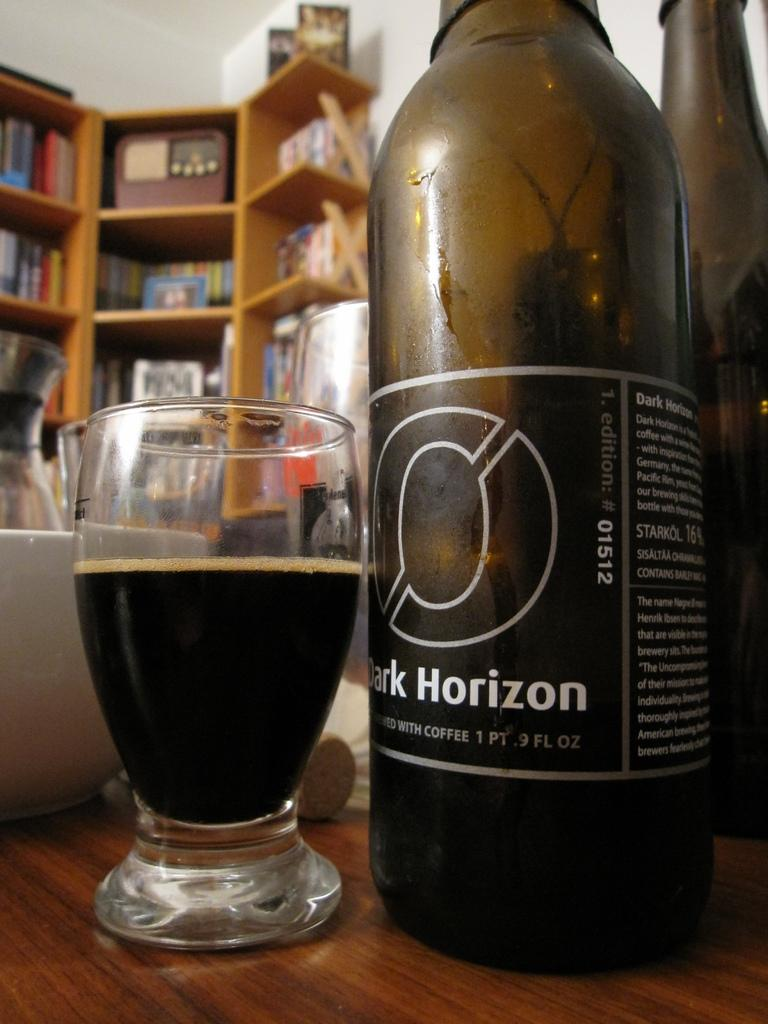<image>
Present a compact description of the photo's key features. A glass next to a bottle of Dark Horizon 